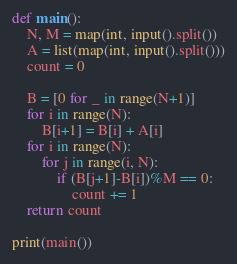Convert code to text. <code><loc_0><loc_0><loc_500><loc_500><_Python_>def main():
    N, M = map(int, input().split())
    A = list(map(int, input().split()))
    count = 0

    B = [0 for _ in range(N+1)]
    for i in range(N):
        B[i+1] = B[i] + A[i]
    for i in range(N):
        for j in range(i, N):
            if (B[j+1]-B[i])%M == 0:
                count += 1
    return count

print(main())
</code> 